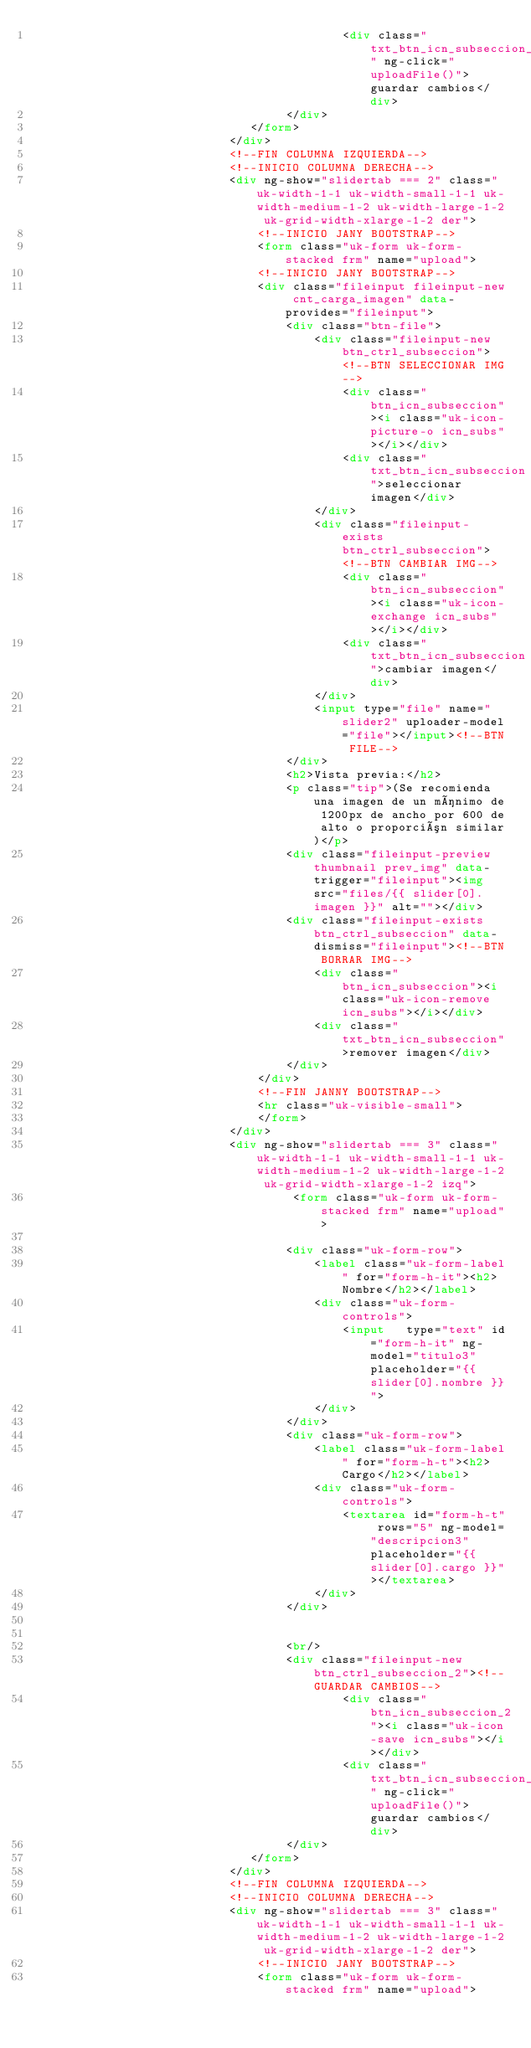Convert code to text. <code><loc_0><loc_0><loc_500><loc_500><_HTML_>                                            <div class="txt_btn_icn_subseccion_2" ng-click="uploadFile()">guardar cambios</div>
                                    </div>
                               </form>
                            </div>
                            <!--FIN COLUMNA IZQUIERDA-->
                            <!--INICIO COLUMNA DERECHA-->
                            <div ng-show="slidertab === 2" class="uk-width-1-1 uk-width-small-1-1 uk-width-medium-1-2 uk-width-large-1-2 uk-grid-width-xlarge-1-2 der">
                                <!--INICIO JANY BOOTSTRAP-->
                                <form class="uk-form uk-form-stacked frm" name="upload">
                                <!--INICIO JANY BOOTSTRAP-->
                                <div class="fileinput fileinput-new cnt_carga_imagen" data-provides="fileinput">
                                    <div class="btn-file">
                                        <div class="fileinput-new btn_ctrl_subseccion"><!--BTN SELECCIONAR IMG-->
                                            <div class="btn_icn_subseccion"><i class="uk-icon-picture-o icn_subs"></i></div>
                                            <div class="txt_btn_icn_subseccion">seleccionar imagen</div>
                                        </div>
                                        <div class="fileinput-exists btn_ctrl_subseccion"><!--BTN CAMBIAR IMG-->
                                            <div class="btn_icn_subseccion"><i class="uk-icon-exchange icn_subs"></i></div>
                                            <div class="txt_btn_icn_subseccion">cambiar imagen</div>
                                        </div>
                                        <input type="file" name="slider2" uploader-model="file"></input><!--BTN FILE-->
                                    </div>
                                    <h2>Vista previa:</h2>
                                    <p class="tip">(Se recomienda una imagen de un mínimo de 1200px de ancho por 600 de alto o proporción similar)</p>
                                    <div class="fileinput-preview thumbnail prev_img" data-trigger="fileinput"><img src="files/{{ slider[0].imagen }}" alt=""></div>
                                    <div class="fileinput-exists btn_ctrl_subseccion" data-dismiss="fileinput"><!--BTN BORRAR IMG-->
                                        <div class="btn_icn_subseccion"><i class="uk-icon-remove icn_subs"></i></div>
                                        <div class="txt_btn_icn_subseccion">remover imagen</div>
                                    </div>
                                </div>
                                <!--FIN JANNY BOOTSTRAP-->
                                <hr class="uk-visible-small">
                                </form>
                            </div>
                            <div ng-show="slidertab === 3" class="uk-width-1-1 uk-width-small-1-1 uk-width-medium-1-2 uk-width-large-1-2 uk-grid-width-xlarge-1-2 izq">
                                     <form class="uk-form uk-form-stacked frm" name="upload">
                               
                                    <div class="uk-form-row">
                                        <label class="uk-form-label" for="form-h-it"><h2>Nombre</h2></label>
                                        <div class="uk-form-controls">
                                            <input   type="text" id="form-h-it" ng-model="titulo3" placeholder="{{ slider[0].nombre }}">
                                        </div>
                                    </div>
                                    <div class="uk-form-row">
                                        <label class="uk-form-label" for="form-h-t"><h2>Cargo</h2></label>
                                        <div class="uk-form-controls">
                                            <textarea id="form-h-t" rows="5" ng-model="descripcion3" placeholder="{{ slider[0].cargo }}"></textarea>
                                        </div>
                                    </div>
                             
                               
                                    <br/>
                                    <div class="fileinput-new btn_ctrl_subseccion_2"><!--GUARDAR CAMBIOS-->
                                            <div class="btn_icn_subseccion_2"><i class="uk-icon-save icn_subs"></i></div>
                                            <div class="txt_btn_icn_subseccion_2" ng-click="uploadFile()">guardar cambios</div>
                                    </div>
                               </form>
                            </div>
                            <!--FIN COLUMNA IZQUIERDA-->
                            <!--INICIO COLUMNA DERECHA-->
                            <div ng-show="slidertab === 3" class="uk-width-1-1 uk-width-small-1-1 uk-width-medium-1-2 uk-width-large-1-2 uk-grid-width-xlarge-1-2 der">
                                <!--INICIO JANY BOOTSTRAP-->
                                <form class="uk-form uk-form-stacked frm" name="upload"></code> 